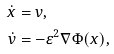Convert formula to latex. <formula><loc_0><loc_0><loc_500><loc_500>\dot { x } & = v , \\ \dot { v } & = - \varepsilon ^ { 2 } \nabla \Phi ( x ) ,</formula> 